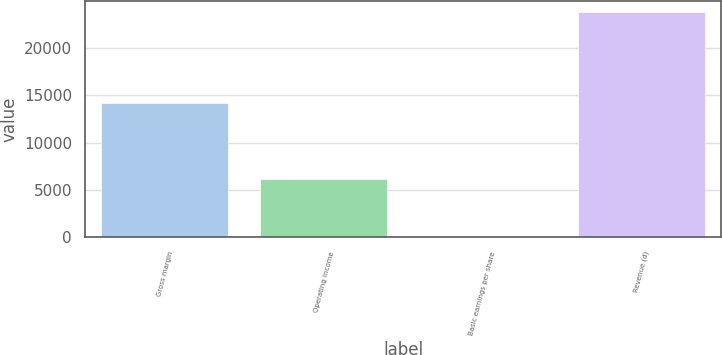<chart> <loc_0><loc_0><loc_500><loc_500><bar_chart><fcel>Gross margin<fcel>Operating income<fcel>Basic earnings per share<fcel>Revenue (d)<nl><fcel>14189<fcel>6177<fcel>0.67<fcel>23796<nl></chart> 